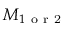<formula> <loc_0><loc_0><loc_500><loc_500>M _ { 1 o r 2 }</formula> 